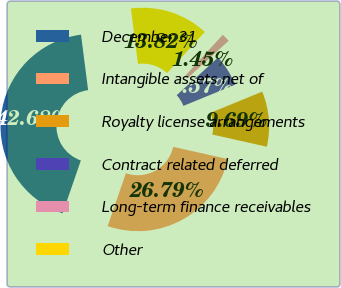Convert chart. <chart><loc_0><loc_0><loc_500><loc_500><pie_chart><fcel>December 31<fcel>Intangible assets net of<fcel>Royalty license arrangements<fcel>Contract related deferred<fcel>Long-term finance receivables<fcel>Other<nl><fcel>42.68%<fcel>26.79%<fcel>9.69%<fcel>5.57%<fcel>1.45%<fcel>13.82%<nl></chart> 